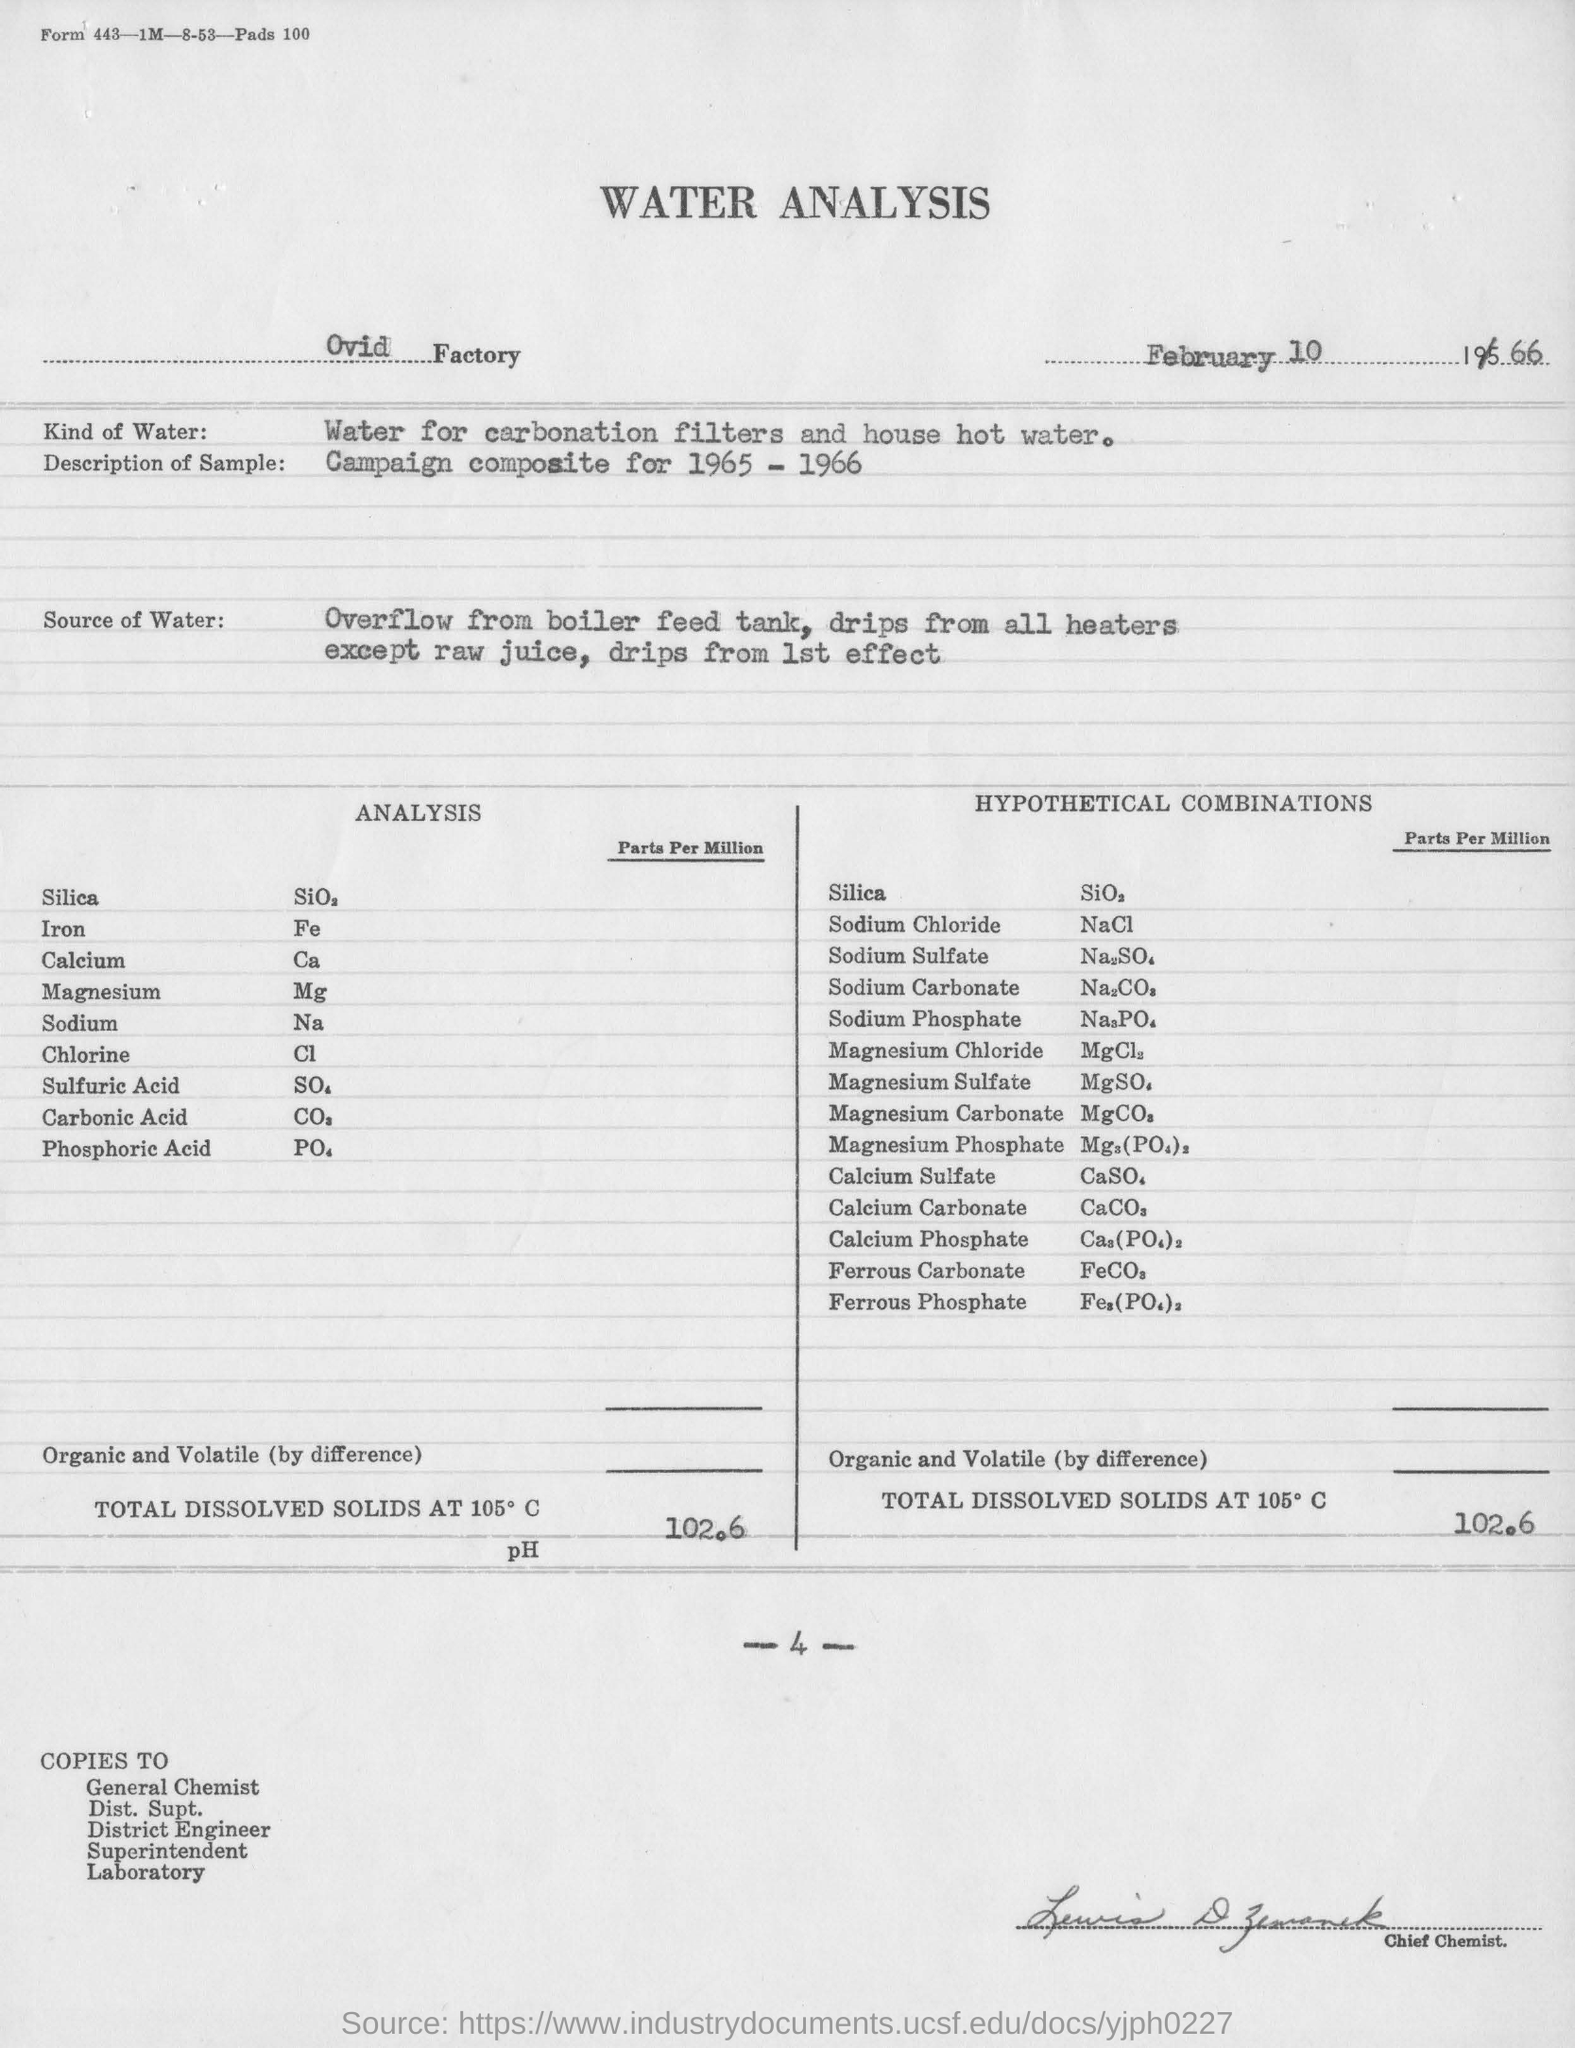In which factory is the water analysis done?
Your answer should be compact. Ovid. What kind of water is used in water analysis ?
Your response must be concise. Water for carbonation filters and house hot water. What is the amount of total dissolved solids at 105 degrees c ?
Give a very brief answer. 102.6. On which date this water analysis is done ?
Provide a short and direct response. February 10 1966. What does nacl  indicates ?
Provide a succinct answer. Sodium Chloride. 